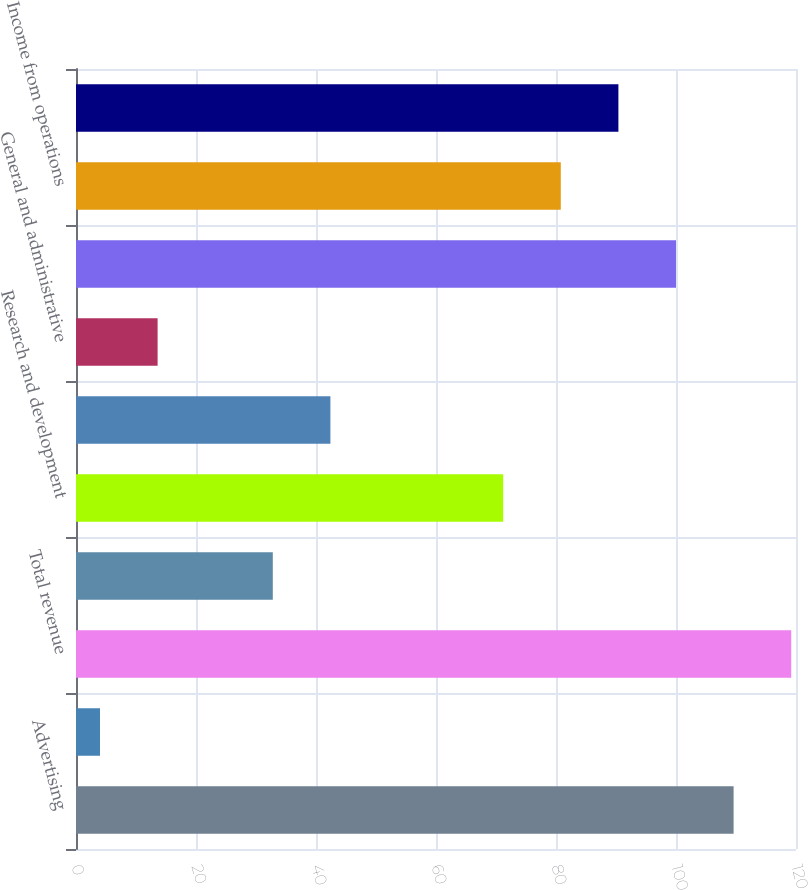Convert chart. <chart><loc_0><loc_0><loc_500><loc_500><bar_chart><fcel>Advertising<fcel>Payments and other fees<fcel>Total revenue<fcel>Cost of revenue<fcel>Research and development<fcel>Marketing and sales<fcel>General and administrative<fcel>Total costs and expenses<fcel>Income from operations<fcel>Income before provision for<nl><fcel>109.6<fcel>4<fcel>119.2<fcel>32.8<fcel>71.2<fcel>42.4<fcel>13.6<fcel>100<fcel>80.8<fcel>90.4<nl></chart> 